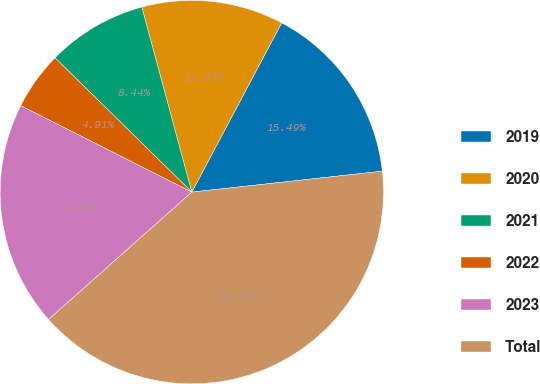Convert chart to OTSL. <chart><loc_0><loc_0><loc_500><loc_500><pie_chart><fcel>2019<fcel>2020<fcel>2021<fcel>2022<fcel>2023<fcel>Total<nl><fcel>15.49%<fcel>11.97%<fcel>8.44%<fcel>4.91%<fcel>19.02%<fcel>40.17%<nl></chart> 